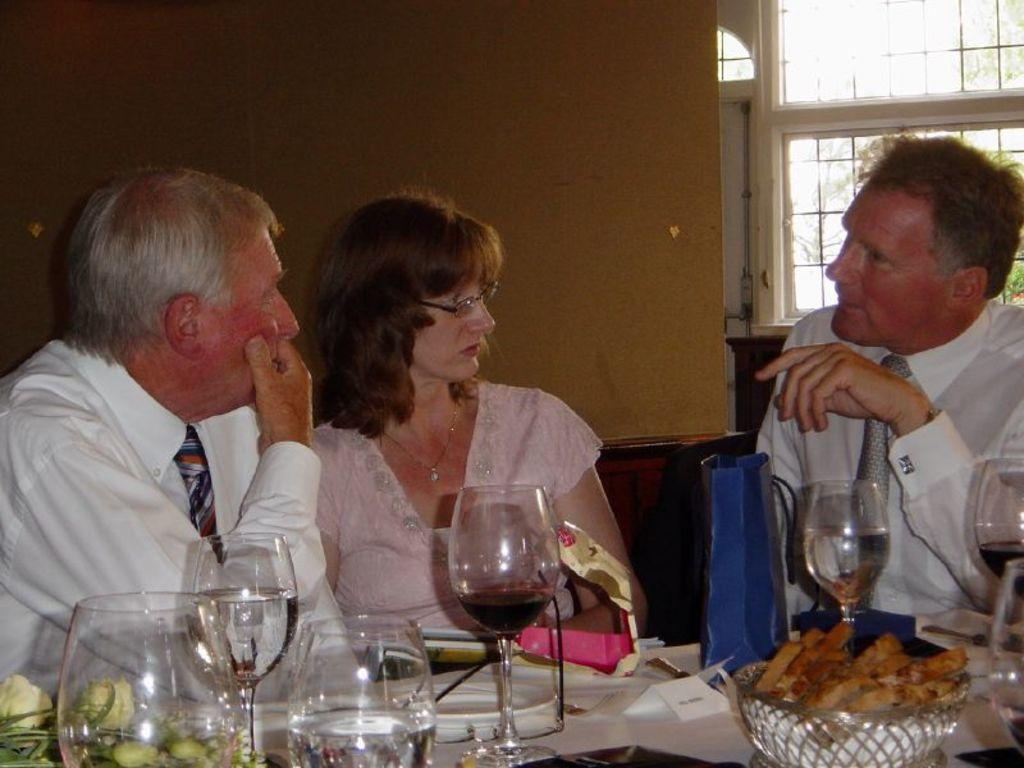How many people are in the image? There are three persons in the image. What can be seen on the table in the image? There are food items and glasses on the table. What is visible in the background of the image? There is a window visible in the background of the image. What type of lettuce is being used to conduct a science experiment in the image? There is no lettuce or science experiment present in the image. What kind of pancake is being served on the table in the image? There is no pancake visible on the table in the image. 